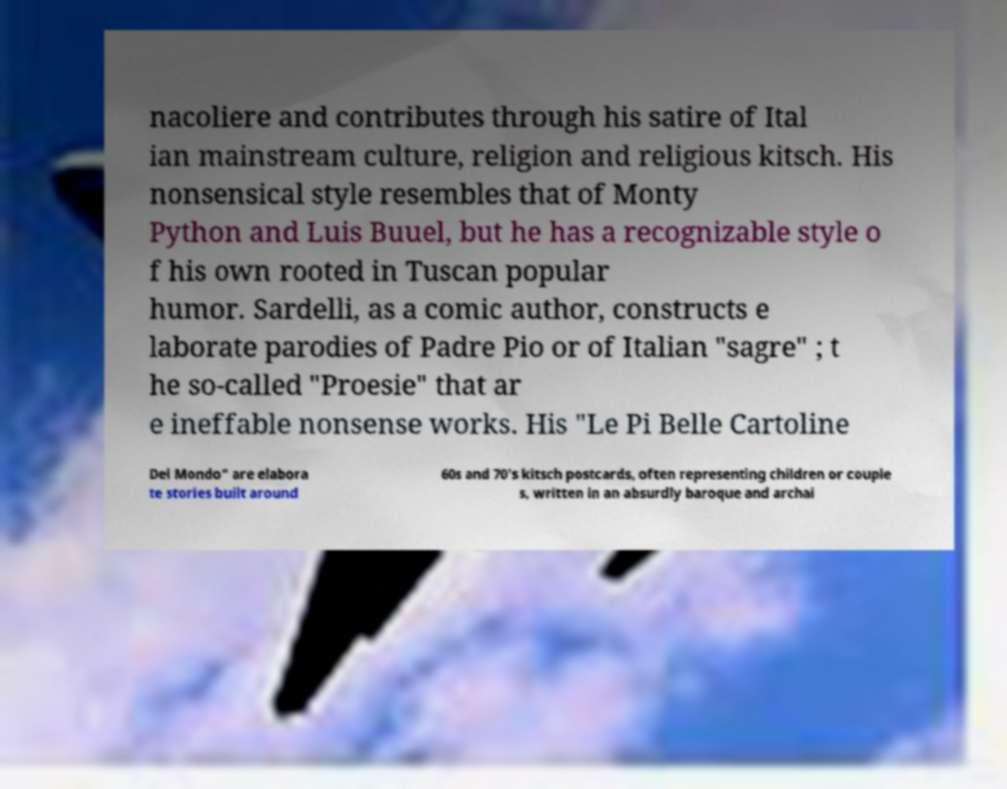Please read and relay the text visible in this image. What does it say? nacoliere and contributes through his satire of Ital ian mainstream culture, religion and religious kitsch. His nonsensical style resembles that of Monty Python and Luis Buuel, but he has a recognizable style o f his own rooted in Tuscan popular humor. Sardelli, as a comic author, constructs e laborate parodies of Padre Pio or of Italian "sagre" ; t he so-called "Proesie" that ar e ineffable nonsense works. His "Le Pi Belle Cartoline Del Mondo" are elabora te stories built around 60s and 70's kitsch postcards, often representing children or couple s, written in an absurdly baroque and archai 